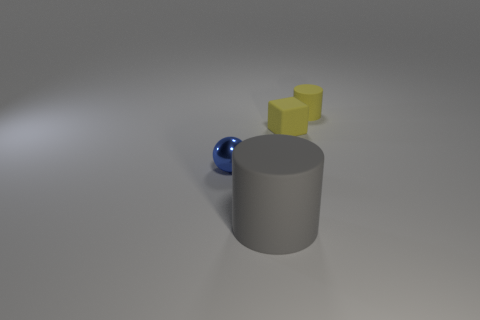Is the number of tiny metal objects greater than the number of tiny gray rubber blocks?
Keep it short and to the point. Yes. Is the number of small cylinders on the left side of the small rubber cylinder greater than the number of blue metal balls to the left of the gray cylinder?
Provide a short and direct response. No. What is the size of the object that is left of the tiny yellow block and to the right of the blue metal object?
Ensure brevity in your answer.  Large. What number of cylinders have the same size as the cube?
Provide a succinct answer. 1. What material is the cylinder that is the same color as the small rubber cube?
Provide a succinct answer. Rubber. Does the tiny object left of the yellow block have the same shape as the large gray thing?
Offer a very short reply. No. Is the number of yellow blocks to the right of the tiny rubber block less than the number of big shiny blocks?
Provide a short and direct response. No. Are there any matte blocks that have the same color as the tiny sphere?
Provide a succinct answer. No. There is a blue thing; does it have the same shape as the tiny yellow rubber object that is in front of the tiny yellow rubber cylinder?
Provide a succinct answer. No. Are there any brown cylinders made of the same material as the tiny cube?
Your response must be concise. No. 